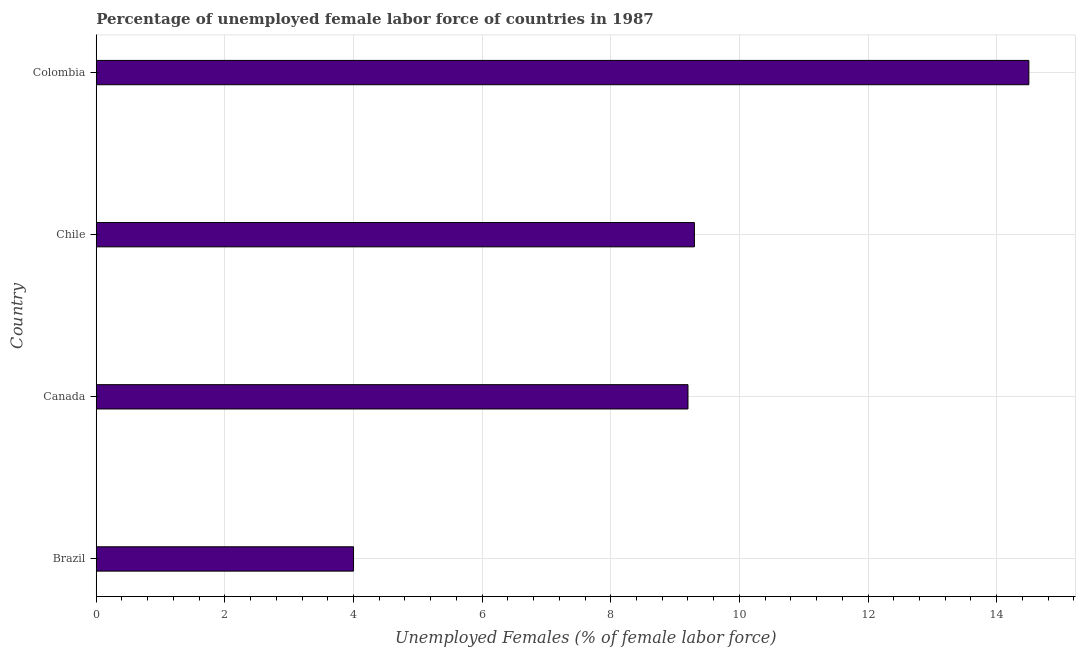Does the graph contain grids?
Provide a succinct answer. Yes. What is the title of the graph?
Provide a short and direct response. Percentage of unemployed female labor force of countries in 1987. What is the label or title of the X-axis?
Provide a short and direct response. Unemployed Females (% of female labor force). What is the total unemployed female labour force in Canada?
Ensure brevity in your answer.  9.2. In which country was the total unemployed female labour force minimum?
Your response must be concise. Brazil. What is the sum of the total unemployed female labour force?
Offer a terse response. 37. What is the difference between the total unemployed female labour force in Brazil and Chile?
Keep it short and to the point. -5.3. What is the average total unemployed female labour force per country?
Your response must be concise. 9.25. What is the median total unemployed female labour force?
Provide a short and direct response. 9.25. In how many countries, is the total unemployed female labour force greater than 12 %?
Provide a short and direct response. 1. What is the ratio of the total unemployed female labour force in Brazil to that in Colombia?
Your answer should be very brief. 0.28. Is the difference between the total unemployed female labour force in Canada and Colombia greater than the difference between any two countries?
Offer a very short reply. No. What is the difference between the highest and the lowest total unemployed female labour force?
Keep it short and to the point. 10.5. How many bars are there?
Provide a short and direct response. 4. Are all the bars in the graph horizontal?
Provide a succinct answer. Yes. How many countries are there in the graph?
Make the answer very short. 4. What is the Unemployed Females (% of female labor force) in Brazil?
Provide a short and direct response. 4. What is the Unemployed Females (% of female labor force) of Canada?
Provide a succinct answer. 9.2. What is the Unemployed Females (% of female labor force) of Chile?
Your answer should be compact. 9.3. What is the Unemployed Females (% of female labor force) of Colombia?
Your response must be concise. 14.5. What is the difference between the Unemployed Females (% of female labor force) in Brazil and Canada?
Your response must be concise. -5.2. What is the difference between the Unemployed Females (% of female labor force) in Brazil and Chile?
Give a very brief answer. -5.3. What is the difference between the Unemployed Females (% of female labor force) in Brazil and Colombia?
Give a very brief answer. -10.5. What is the ratio of the Unemployed Females (% of female labor force) in Brazil to that in Canada?
Provide a succinct answer. 0.43. What is the ratio of the Unemployed Females (% of female labor force) in Brazil to that in Chile?
Offer a terse response. 0.43. What is the ratio of the Unemployed Females (% of female labor force) in Brazil to that in Colombia?
Provide a short and direct response. 0.28. What is the ratio of the Unemployed Females (% of female labor force) in Canada to that in Chile?
Make the answer very short. 0.99. What is the ratio of the Unemployed Females (% of female labor force) in Canada to that in Colombia?
Provide a short and direct response. 0.63. What is the ratio of the Unemployed Females (% of female labor force) in Chile to that in Colombia?
Make the answer very short. 0.64. 